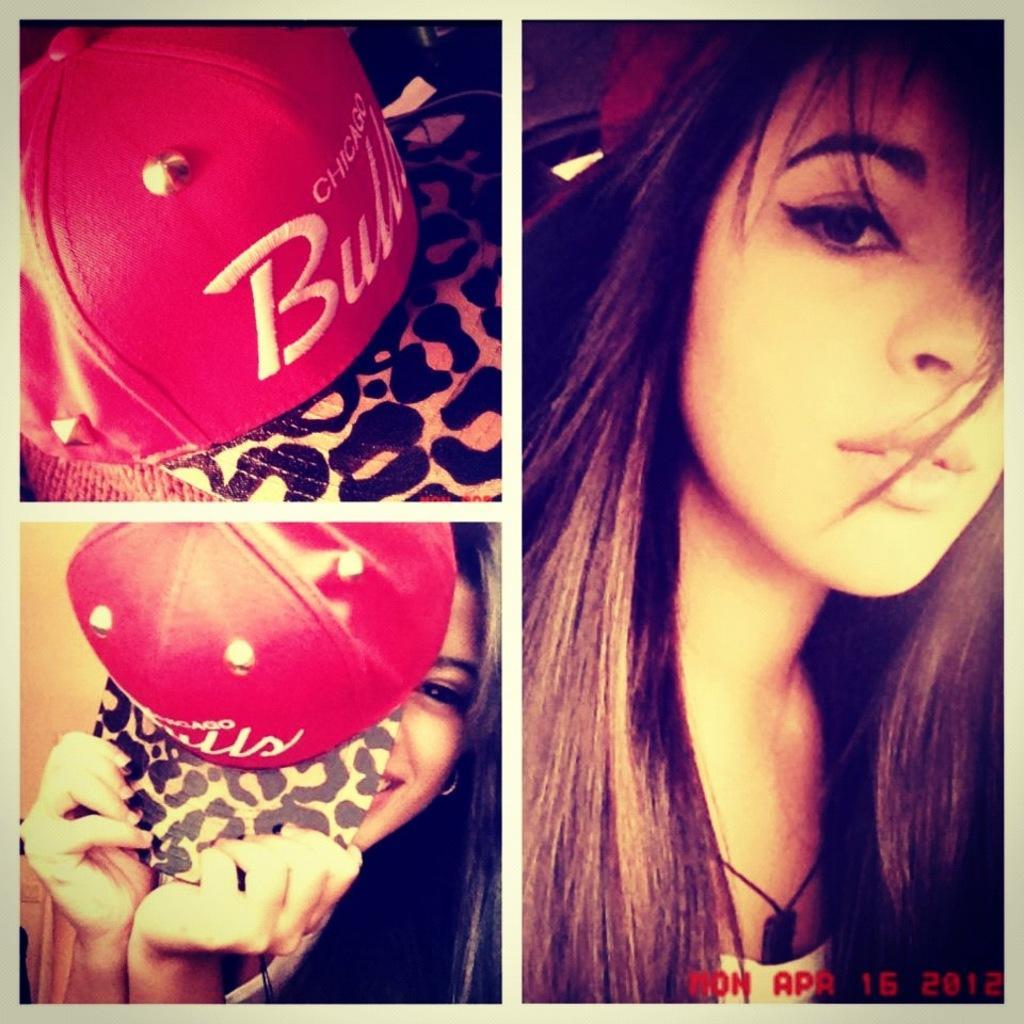Describe this image in one or two sentences. In this image we can see a collage. In the left top image we can see a cap. In the left bottom image we can see a lady holding a cap. On the right image we can see a lady. In the right bottom corner something is written. 